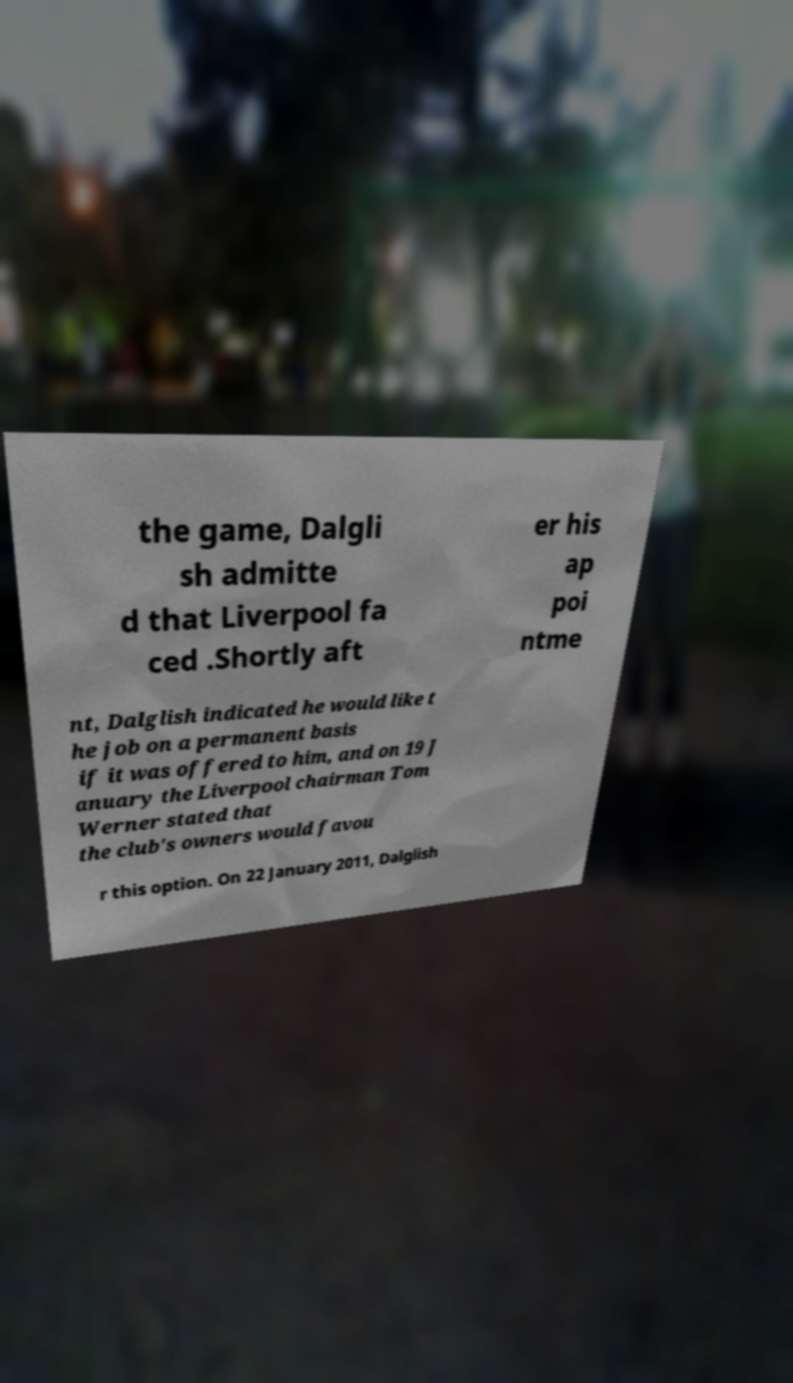Could you extract and type out the text from this image? the game, Dalgli sh admitte d that Liverpool fa ced .Shortly aft er his ap poi ntme nt, Dalglish indicated he would like t he job on a permanent basis if it was offered to him, and on 19 J anuary the Liverpool chairman Tom Werner stated that the club's owners would favou r this option. On 22 January 2011, Dalglish 